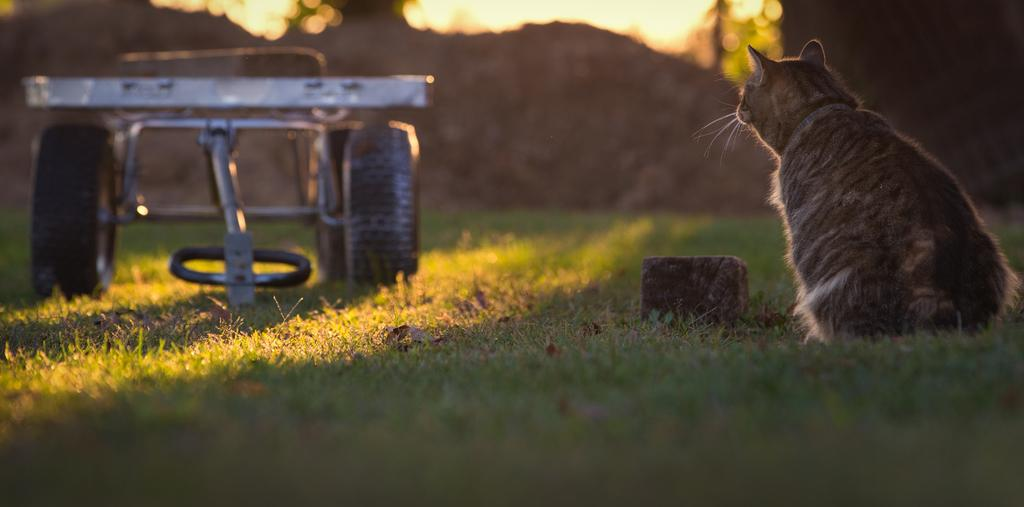What type of animal is in the image? There is a cat in the image. What material is the wooden object made of? The wooden object in the image is made of wood. What can be seen in the image besides the cat and wooden object? There is a vehicle in the image. What type of natural environment is visible in the background of the image? There is grass in the background of the image. What type of jam is the cat spreading on the wooden object in the image? There is no jam or any indication of spreading in the image; it only features a cat, a wooden object, a vehicle, and grass in the background. 